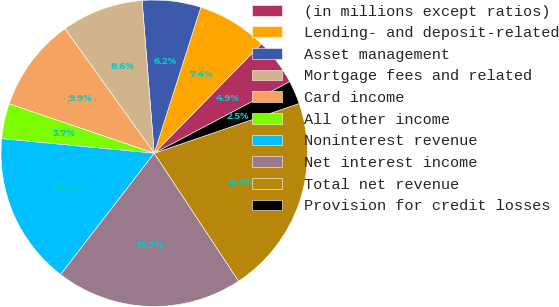<chart> <loc_0><loc_0><loc_500><loc_500><pie_chart><fcel>(in millions except ratios)<fcel>Lending- and deposit-related<fcel>Asset management<fcel>Mortgage fees and related<fcel>Card income<fcel>All other income<fcel>Noninterest revenue<fcel>Net interest income<fcel>Total net revenue<fcel>Provision for credit losses<nl><fcel>4.94%<fcel>7.41%<fcel>6.18%<fcel>8.64%<fcel>9.88%<fcel>3.71%<fcel>16.05%<fcel>19.75%<fcel>20.98%<fcel>2.47%<nl></chart> 